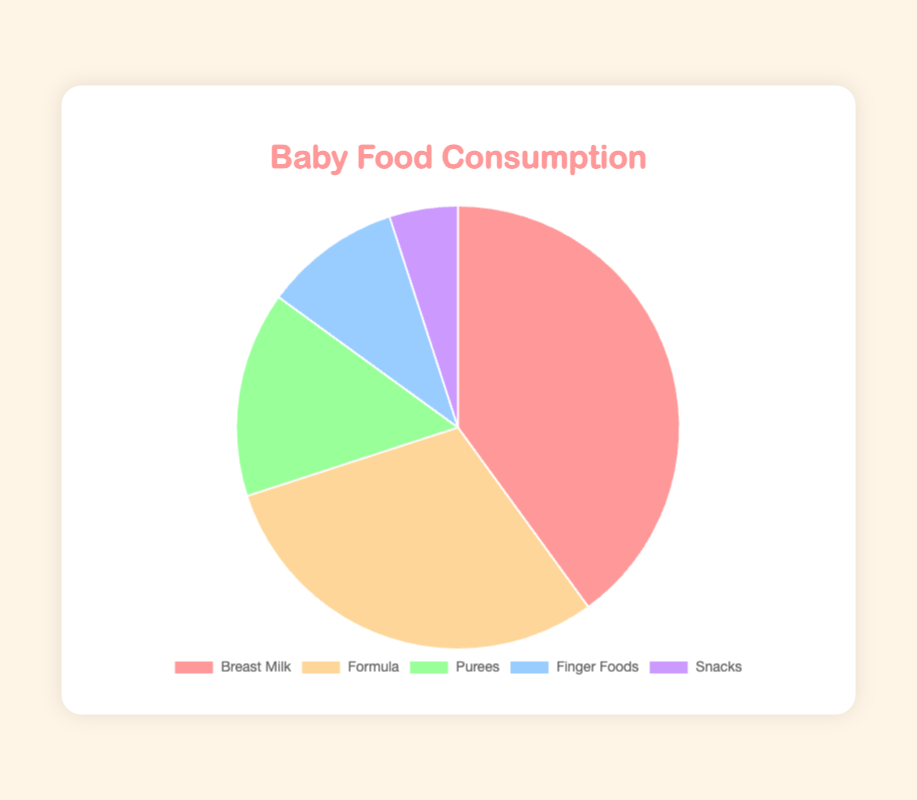Which type of baby food is consumed the most by infants? The pie chart shows that "Breast Milk" occupies the largest segment.
Answer: Breast Milk What percentage of infants consume purees? Referring to the chart, "Purees (e.g., mashed fruits/vegetables)" occupies 15% of the chart.
Answer: 15% Which type of baby food is consumed the least by infants? The smallest segment of the pie chart represents "Snacks (e.g., baby biscuits, puffs)", which occupies 5%.
Answer: Snacks How much more breast milk is consumed compared to formula? Breast Milk is at 40% while Formula is at 30%. The difference is 40% - 30% = 10%.
Answer: 10% What is the total percentage of infants consuming either purees or finger foods? Purees account for 15% and Finger Foods for 10%. Adding their percentages: 15% + 10% = 25%.
Answer: 25% Which type of baby food has a larger percentage: finger foods or snacks? Finger Foods occupy 10% while Snacks occupy 5%. Therefore, Finger Foods have a larger percentage.
Answer: Finger Foods What is the combined percentage of infants consuming formula and snacks? Formula is 30% and Snacks is 5%. Adding their percentages: 30% + 5% = 35%.
Answer: 35% Arrange the types of baby food in descending order of consumption percentage. From the pie chart, the order from largest to smallest is: Breast Milk (40%), Formula (30%), Purees (15%), Finger Foods (10%), Snacks (5%).
Answer: Breast Milk > Formula > Purees > Finger Foods > Snacks 